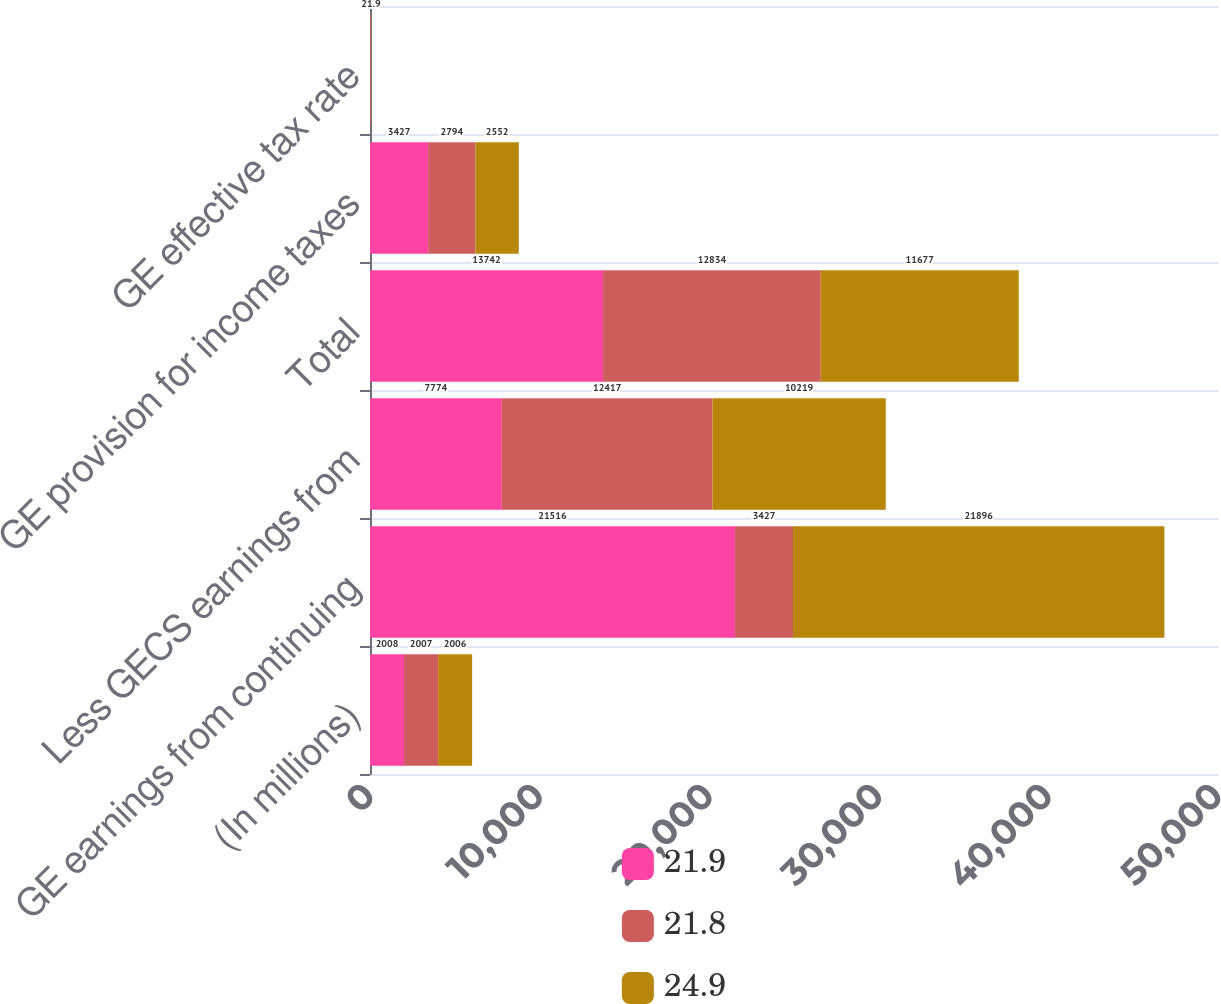<chart> <loc_0><loc_0><loc_500><loc_500><stacked_bar_chart><ecel><fcel>(In millions)<fcel>GE earnings from continuing<fcel>Less GECS earnings from<fcel>Total<fcel>GE provision for income taxes<fcel>GE effective tax rate<nl><fcel>21.9<fcel>2008<fcel>21516<fcel>7774<fcel>13742<fcel>3427<fcel>24.9<nl><fcel>21.8<fcel>2007<fcel>3427<fcel>12417<fcel>12834<fcel>2794<fcel>21.8<nl><fcel>24.9<fcel>2006<fcel>21896<fcel>10219<fcel>11677<fcel>2552<fcel>21.9<nl></chart> 